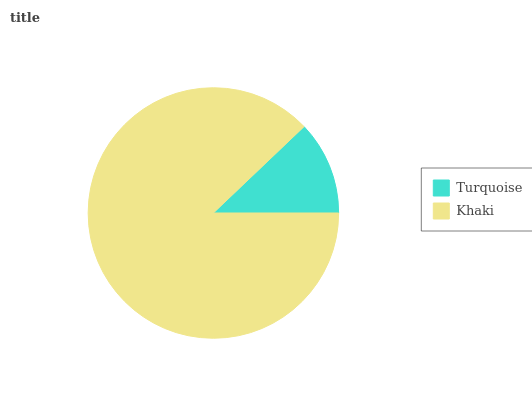Is Turquoise the minimum?
Answer yes or no. Yes. Is Khaki the maximum?
Answer yes or no. Yes. Is Khaki the minimum?
Answer yes or no. No. Is Khaki greater than Turquoise?
Answer yes or no. Yes. Is Turquoise less than Khaki?
Answer yes or no. Yes. Is Turquoise greater than Khaki?
Answer yes or no. No. Is Khaki less than Turquoise?
Answer yes or no. No. Is Khaki the high median?
Answer yes or no. Yes. Is Turquoise the low median?
Answer yes or no. Yes. Is Turquoise the high median?
Answer yes or no. No. Is Khaki the low median?
Answer yes or no. No. 